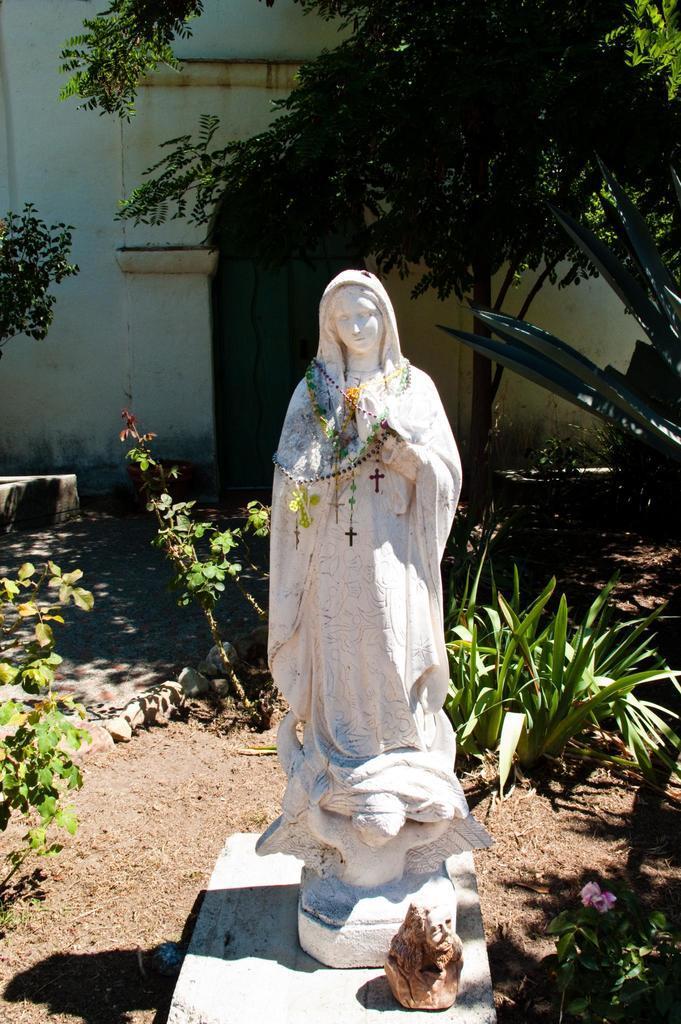How would you summarize this image in a sentence or two? In this image I can see a statue of a woman with some cross marks hanging on her neck. I can see another stone at the bottom of the image. I can see plants, trees, a building and its entrance behind the statue. 